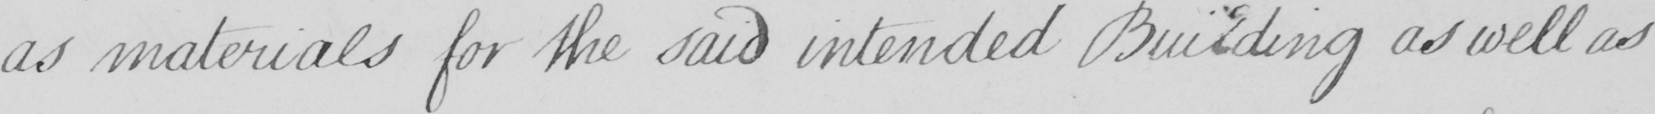What is written in this line of handwriting? as materials for the said intended Building as well as 